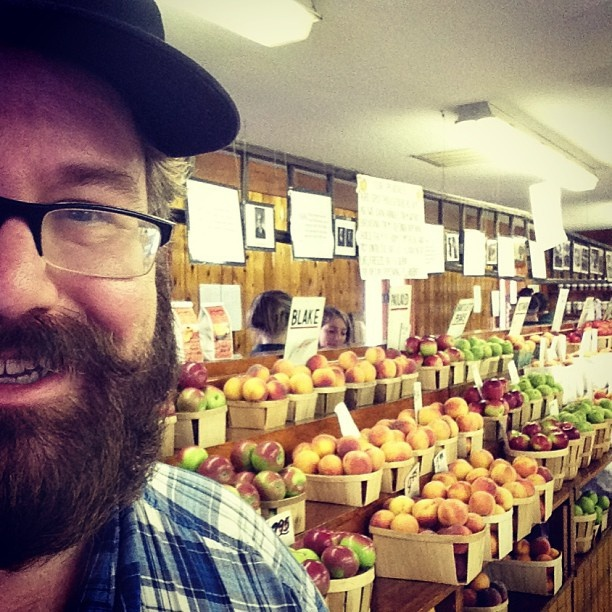Describe the objects in this image and their specific colors. I can see people in gray, black, brown, purple, and navy tones, apple in black, olive, brown, maroon, and khaki tones, people in black, gray, and purple tones, apple in black, maroon, and brown tones, and apple in black, brown, olive, and tan tones in this image. 